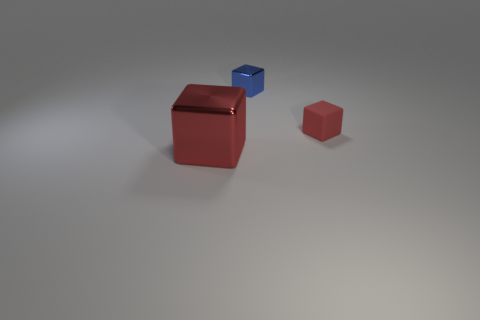Subtract all big red metal cubes. How many cubes are left? 2 Subtract all gray balls. How many red blocks are left? 2 Add 3 large red metallic things. How many objects exist? 6 Add 2 large cubes. How many large cubes are left? 3 Add 1 small red shiny cubes. How many small red shiny cubes exist? 1 Subtract 0 cyan cylinders. How many objects are left? 3 Subtract all yellow cubes. Subtract all brown spheres. How many cubes are left? 3 Subtract all large purple matte objects. Subtract all big red things. How many objects are left? 2 